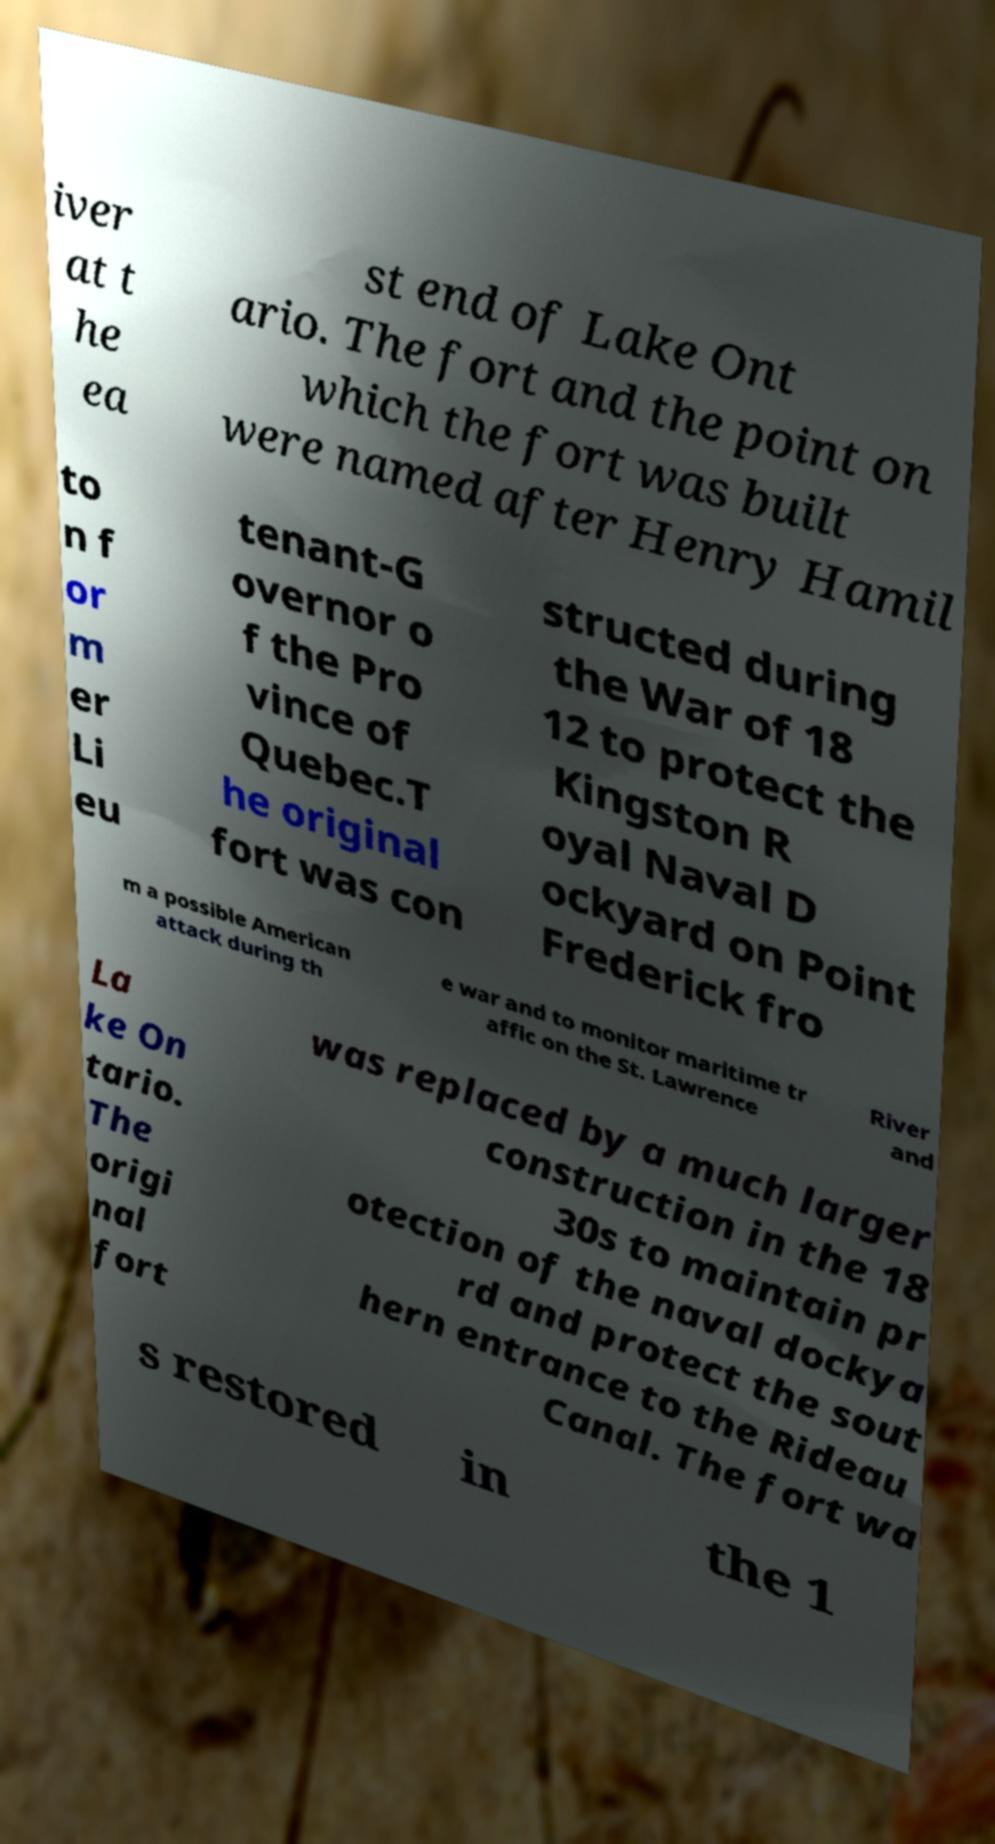Could you extract and type out the text from this image? iver at t he ea st end of Lake Ont ario. The fort and the point on which the fort was built were named after Henry Hamil to n f or m er Li eu tenant-G overnor o f the Pro vince of Quebec.T he original fort was con structed during the War of 18 12 to protect the Kingston R oyal Naval D ockyard on Point Frederick fro m a possible American attack during th e war and to monitor maritime tr affic on the St. Lawrence River and La ke On tario. The origi nal fort was replaced by a much larger construction in the 18 30s to maintain pr otection of the naval dockya rd and protect the sout hern entrance to the Rideau Canal. The fort wa s restored in the 1 